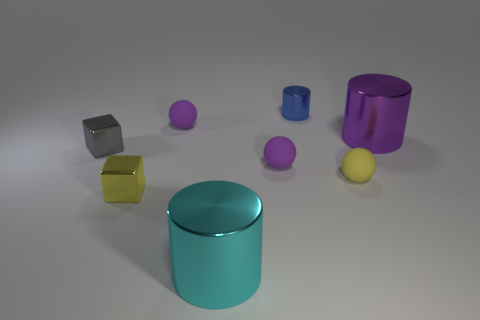What do the colors of the objects suggest about the mood or theme of this image? The bright and varied colors of the objects—ranging from yellow and blue to purple—give the image a playful and creative mood. The vibrancy could suggest inspiration or an invitation to think outside the box, as the objects resemble toys or building blocks. This type of color usage might evoke curiosity and a sense of childish wonder or could be part of a visual exercise in color theory or spatial design. 